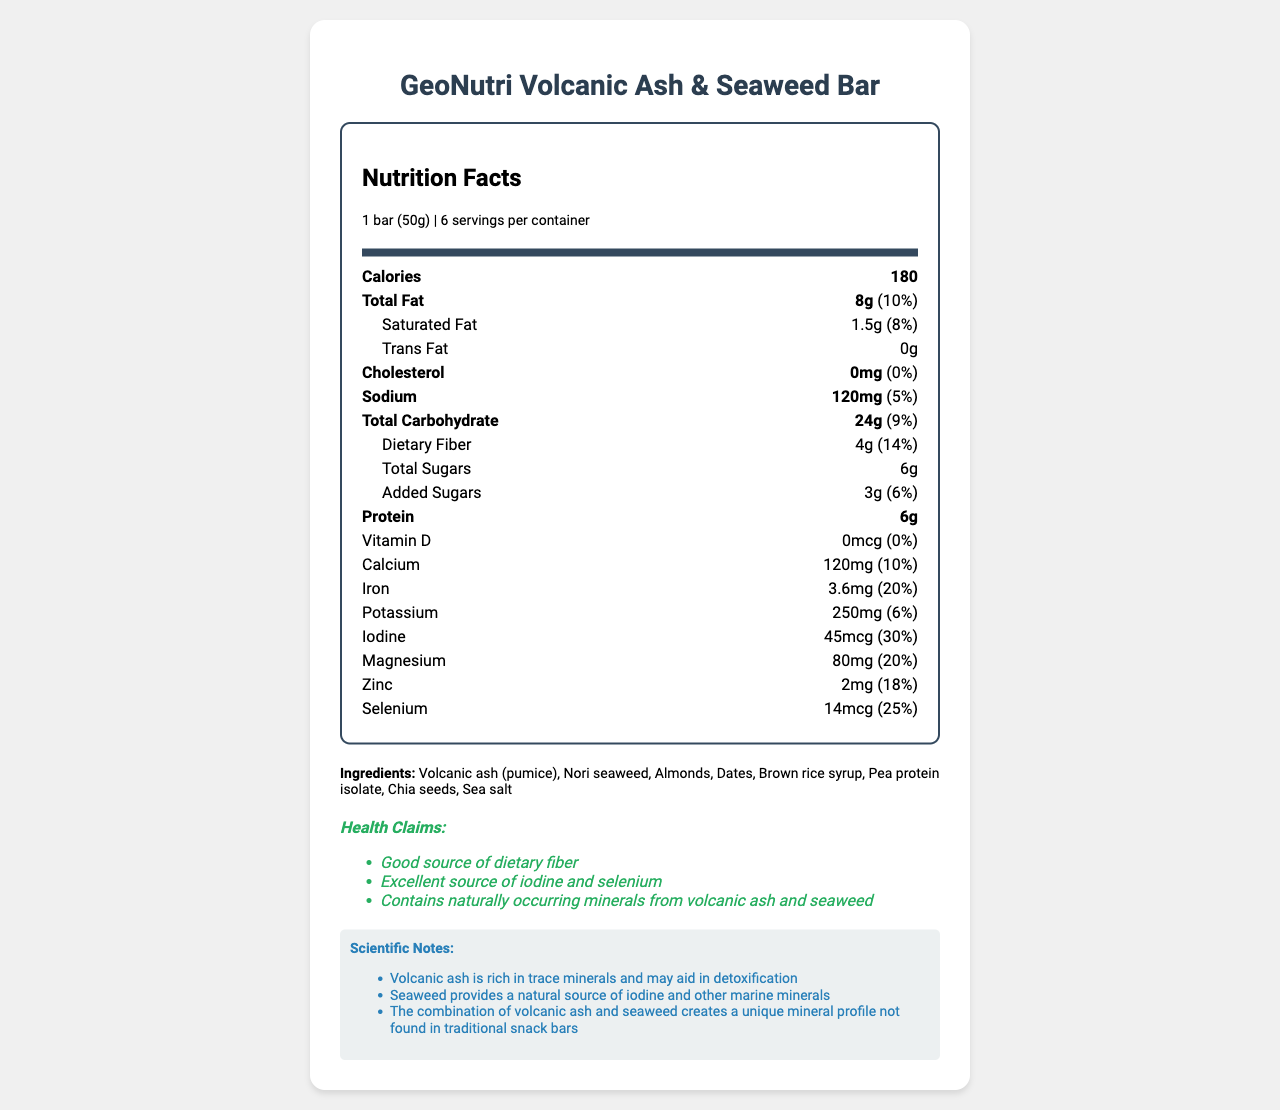what is the serving size of the GeoNutri Volcanic Ash & Seaweed Bar? The serving size is stated at the beginning of the nutrition facts label.
Answer: 1 bar (50g) how many servings are there per container? The number of servings per container is mentioned at the top of the nutrition facts label.
Answer: 6 how much protein is in one serving of the snack bar? The amount of protein is listed in the nutrition label under the heading "Protein."
Answer: 6g what are the main ingredients in this snack bar? The list of ingredients is provided at the bottom part of the document under "Ingredients."
Answer: Volcanic ash (pumice), Nori seaweed, Almonds, Dates, Brown rice syrup, Pea protein isolate, Chia seeds, Sea salt what percent of your daily iron needs does one serving provide? The daily value percentage for iron is specified under the "Iron" section of the nutritional values.
Answer: 20% which nutrient has the highest daily value percentage? A. Calcium B. Iodine C. Selenium D. Magnesium The daily value percentages for each nutrient are listed in the nutrition facts. Iodine has the highest daily value percentage at 30%.
Answer: B. Iodine how many grams of total sugars are in one bar? The total sugars are listed under the "Total Sugars" section of the nutrition facts.
Answer: 6g is this product a good source of dietary fiber? A. Yes B. No C. Cannot be determined The label contains a health claim stating that this snack bar is a "Good source of dietary fiber."
Answer: A. Yes does the snack bar contain any tree nuts? The allergen information at the bottom of the document states that the product contains tree nuts (almonds).
Answer: Yes how much sodium does one serving contain? The amount of sodium is specified in the nutrition facts under the "Sodium" section.
Answer: 120mg what minerals are mentioned in the scientific notes? The scientific notes state that volcanic ash is rich in trace minerals, and seaweed provides iodine and other marine minerals.
Answer: Iodine, Selenium, Other marine minerals, Trace minerals from volcanic ash is there any vitamin D in the GeoNutri Volcanic Ash & Seaweed Bar? The amount of vitamin D is listed as 0mcg in the nutrition facts.
Answer: No what are the health claims made about this product? Summarize them in one or two sentences. The health claims section lists these specific benefits, highlighting the mineral content and dietary fiber.
Answer: The snack bar is a good source of dietary fiber, an excellent source of iodine and selenium, and contains naturally occurring minerals from volcanic ash and seaweed. how much selenium is in one serving of the snack bar? The amount of selenium is specified in the nutrition facts.
Answer: 14mcg can you determine the manufacturer of this snack bar from the document? The manufacturer is mentioned at the bottom of the document under the "manufacturer" section.
Answer: Yes, GeoNutri Labs, Inc. how many grams of dietary fiber are included in one serving? The dietary fiber content is provided in the nutrition facts under the "Dietary Fiber" section.
Answer: 4g what is the total number of calories in one container of this snack bar? Each serving contains 180 calories, and there are 6 servings per container. Hence, 180 calories/serving * 6 servings = 1080 calories.
Answer: 1080 calories how much added sugars are in one serving? The amount of added sugars is listed under the "Added Sugars" section in the nutrition facts.
Answer: 3g what is the most unique ingredient of this snack bar? The use of volcanic ash is unique and is specifically highlighted in both the ingredients list and the scientific notes.
Answer: Volcanic ash (pumice) what benefits are associated with volcanic ash in the scientific notes? A. Rich in vitamins B. Rich in trace minerals C. High in protein D. Source of healthy fats The scientific notes section mentions that volcanic ash is rich in trace minerals.
Answer: B. Rich in trace minerals based on the information given, can you tell if the product is suitable for vegans? The document does not explicitly state whether the product is suitable for vegans, despite listing all the ingredients.
Answer: Not enough information what valuable minerals does seaweed add to the snack bar? The scientific notes mention that seaweed provides a natural source of iodine and other marine minerals.
Answer: Iodine and other marine minerals explain the main idea of the document. This summary encapsulates the content and purpose of the nutrition facts label, which details the composition and benefits of the snack bar.
Answer: The document provides nutritional information for the GeoNutri Volcanic Ash & Seaweed Bar, including its ingredients, nutritional content, health claims, and scientific notes about the benefits of volcanic ash and seaweed. 